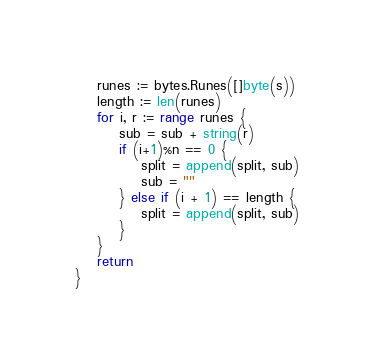<code> <loc_0><loc_0><loc_500><loc_500><_Go_>	runes := bytes.Runes([]byte(s))
	length := len(runes)
	for i, r := range runes {
		sub = sub + string(r)
		if (i+1)%n == 0 {
			split = append(split, sub)
			sub = ""
		} else if (i + 1) == length {
			split = append(split, sub)
		}
	}
	return
}
</code> 